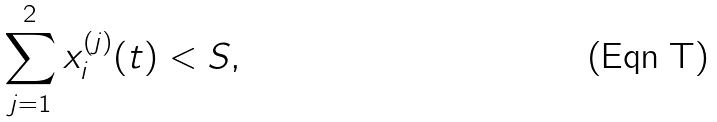<formula> <loc_0><loc_0><loc_500><loc_500>\sum _ { j = 1 } ^ { 2 } x ^ { ( j ) } _ { i } ( t ) < S ,</formula> 